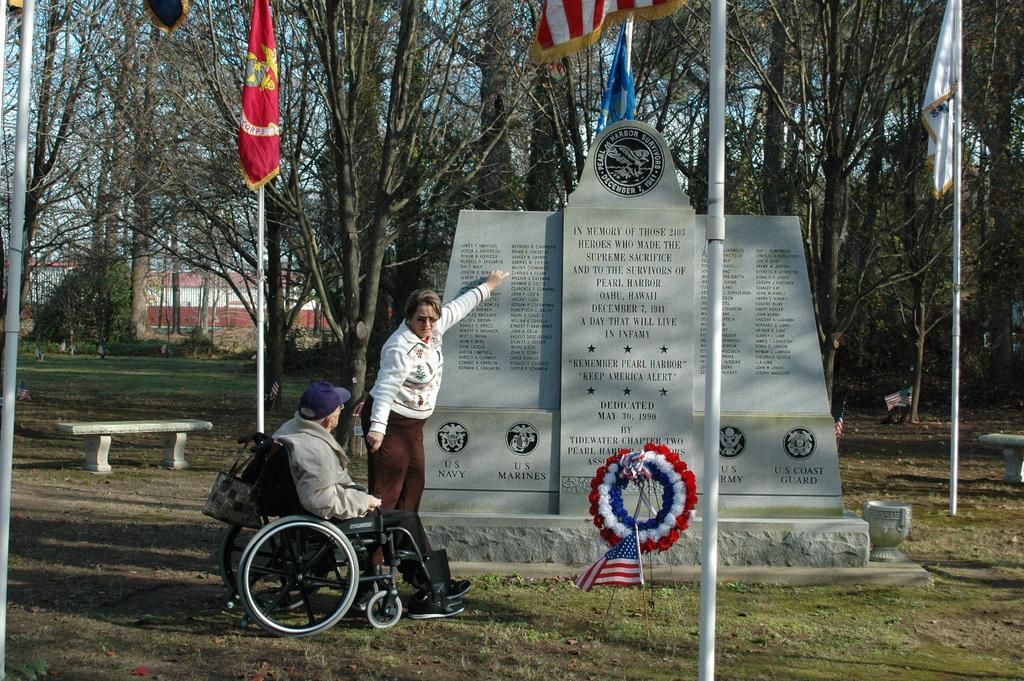Could you give a brief overview of what you see in this image? This is an outside view. Here I can see a man is sitting on the wheel chair and a woman is standing and pointing out at the memorial which is at the back of her and looking at this man. On the left side there is a bench. In the background, I can see some flags, poles and trees. At the bottom of the image I can see the grass. In the background there is a building. 